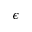Convert formula to latex. <formula><loc_0><loc_0><loc_500><loc_500>\epsilon</formula> 